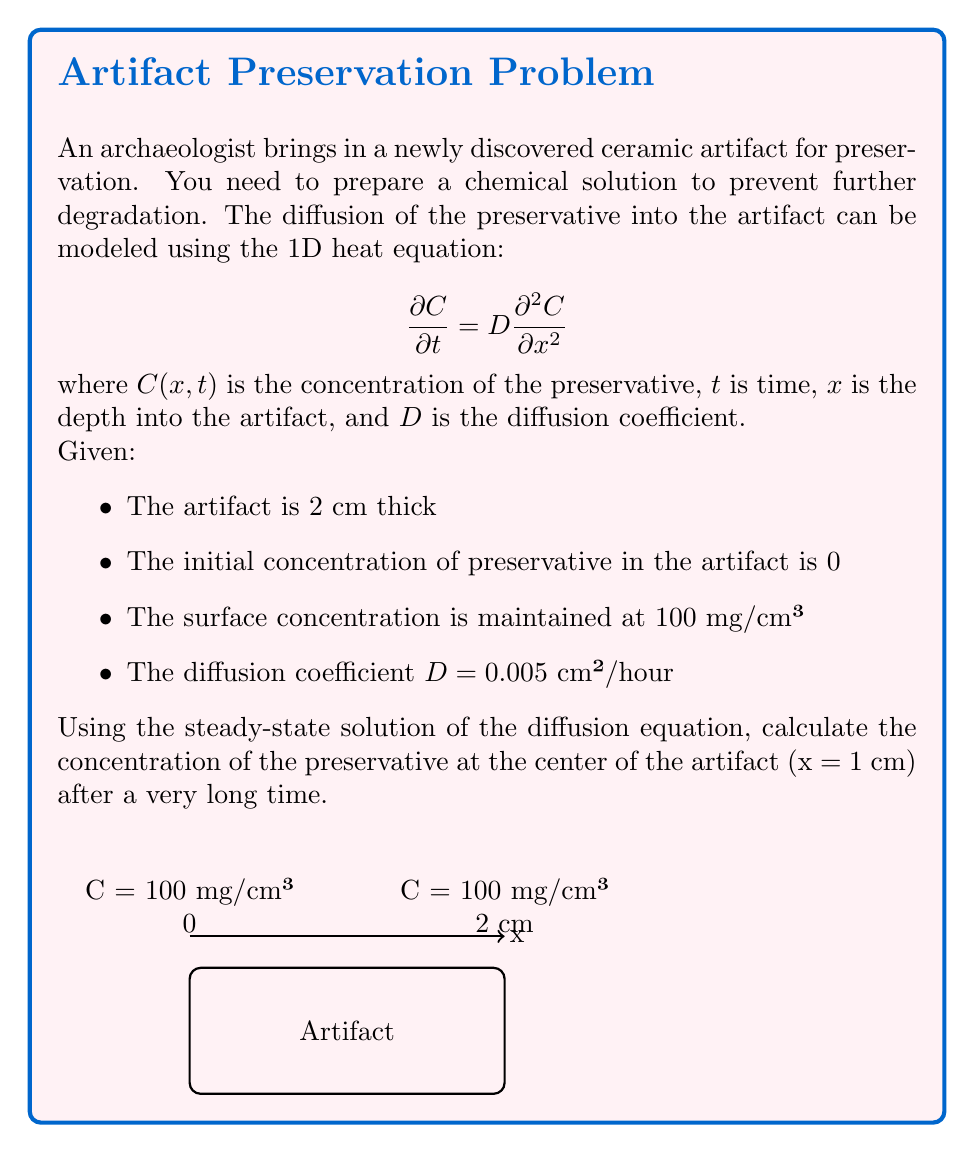Solve this math problem. To solve this problem, we'll follow these steps:

1) The steady-state solution of the 1D diffusion equation is given by:

   $$C(x) = Ax + B$$

   where A and B are constants determined by the boundary conditions.

2) The boundary conditions are:
   At x = 0, C = 100 mg/cm³
   At x = 2 cm, C = 100 mg/cm³

3) Applying these conditions:
   At x = 0: 100 = B
   At x = 2: 100 = 2A + B

4) From the first condition, B = 100.
   Substituting this into the second condition:
   100 = 2A + 100
   0 = 2A
   A = 0

5) Therefore, the steady-state solution is:
   $$C(x) = 100$$

6) This means that after a very long time, the concentration will be uniform throughout the artifact at 100 mg/cm³.

7) At the center of the artifact (x = 1 cm), the concentration will also be 100 mg/cm³.

Note: The diffusion coefficient D and the artifact thickness are not needed for the steady-state solution, but they would be important for calculating how long it takes to reach this state.
Answer: 100 mg/cm³ 